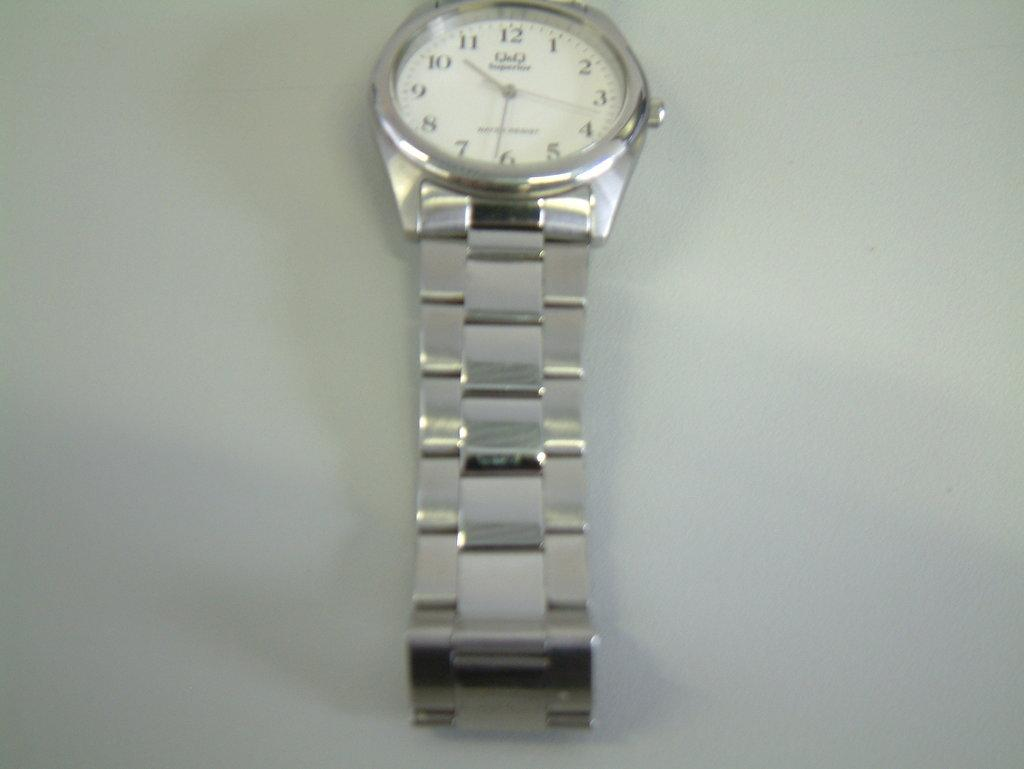<image>
Create a compact narrative representing the image presented. Silver watch which says Q&Q on the front. 